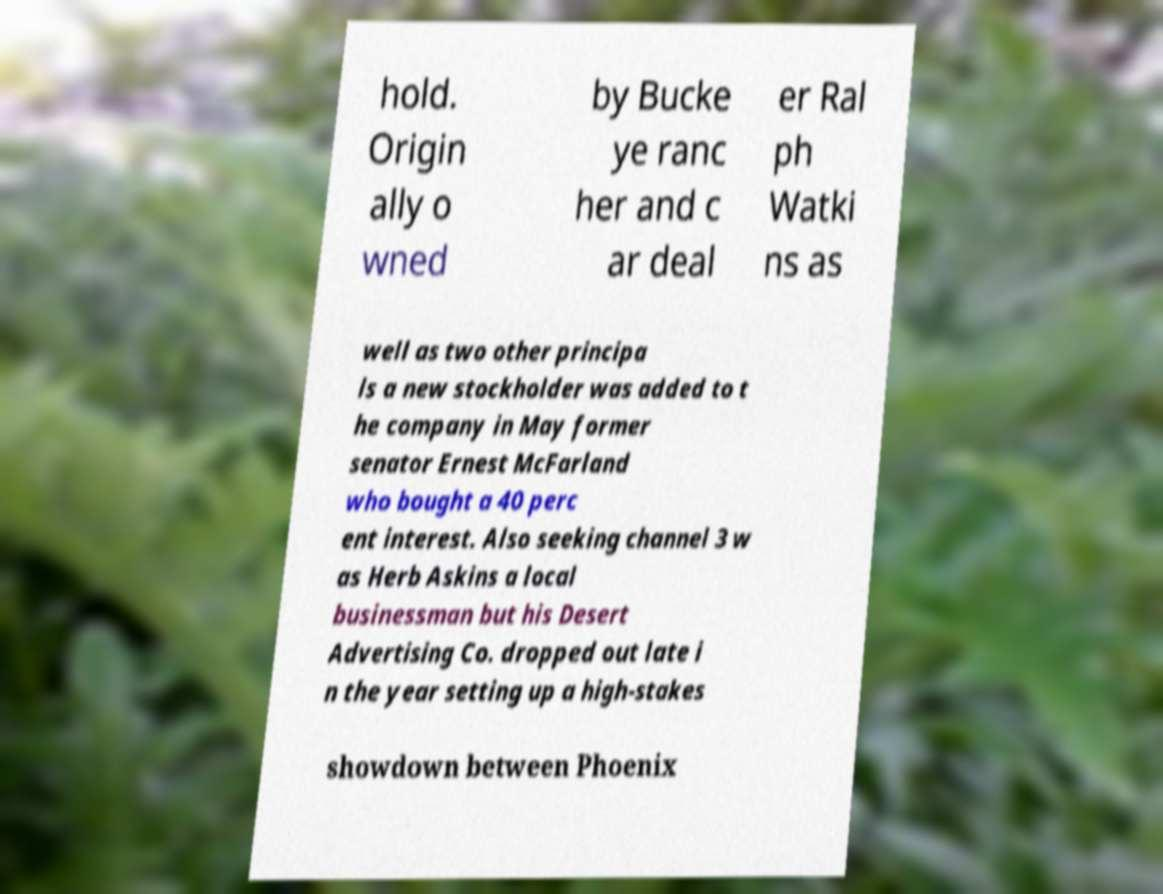Please read and relay the text visible in this image. What does it say? hold. Origin ally o wned by Bucke ye ranc her and c ar deal er Ral ph Watki ns as well as two other principa ls a new stockholder was added to t he company in May former senator Ernest McFarland who bought a 40 perc ent interest. Also seeking channel 3 w as Herb Askins a local businessman but his Desert Advertising Co. dropped out late i n the year setting up a high-stakes showdown between Phoenix 